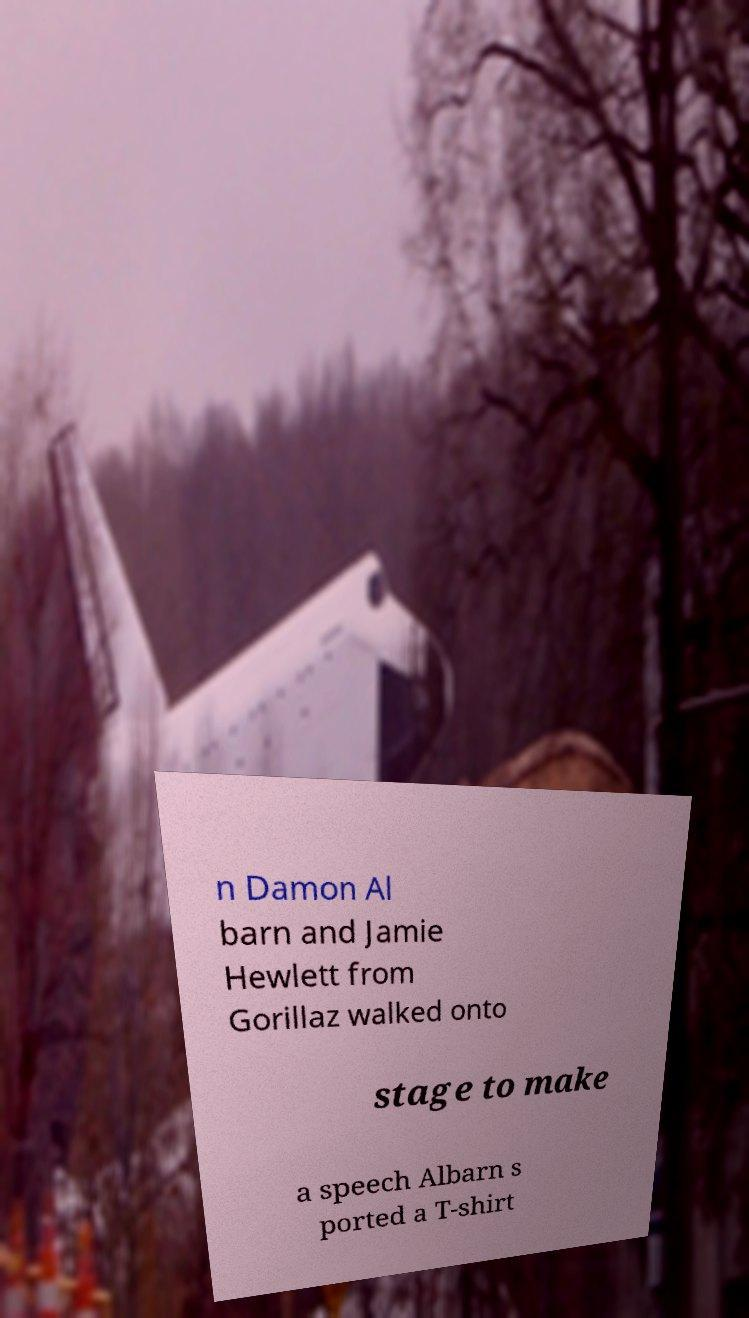For documentation purposes, I need the text within this image transcribed. Could you provide that? n Damon Al barn and Jamie Hewlett from Gorillaz walked onto stage to make a speech Albarn s ported a T-shirt 